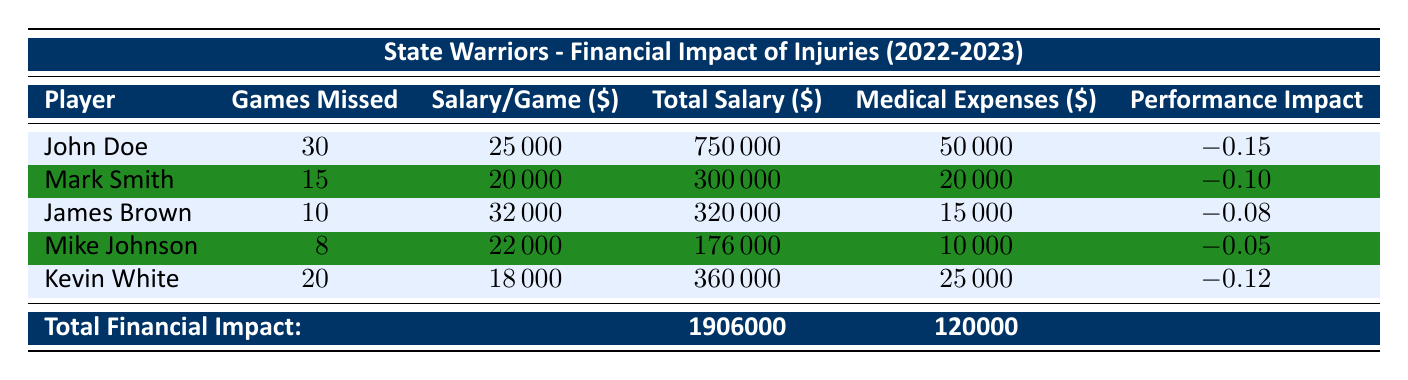What is the total salary payment for John Doe while injured? John Doe missed 30 games, and his salary per game is $25,000. To find the total salary payment while injured, multiply the number of games missed by the salary per game: 30 games * $25,000/game = $750,000.
Answer: 750000 How many games did Mark Smith miss due to injury? Directly from the table, Mark Smith's entry shows he missed 15 games.
Answer: 15 What is the total medical expenses incurred for all players listed? To find the total medical expenses, we add the medical expenses for each player: $50,000 (John Doe) + $20,000 (Mark Smith) + $15,000 (James Brown) + $10,000 (Mike Johnson) + $25,000 (Kevin White) = $120,000.
Answer: 120000 Is the performance impact for Mike Johnson positive? Mike Johnson's performance impact is -0.05, which is negative. This indicates that his absence negatively affected the team's performance.
Answer: No Who missed the most games due to injuries among the players listed? By examining the games missed for each player, John Doe missed 30 games, which is the highest among all the players.
Answer: John Doe What is the average salary per game of all the injured players? To calculate the average, first sum the salaries per game: $25,000 (John Doe) + $20,000 (Mark Smith) + $32,000 (James Brown) + $22,000 (Mike Johnson) + $18,000 (Kevin White) = $117,000. Then divide by the number of players (5): $117,000 / 5 = $23,400.
Answer: 23400 What is the impact on team performance if all injured players are considered together? To find the overall impact, average the performance impacts of all players: (-0.15 + -0.10 + -0.08 + -0.05 + -0.12) / 5 = -0.10. This indicates the cumulative effect of injuries on overall team performance.
Answer: -0.10 Did any player incur more than $25,000 in medical expenses? Yes, John Doe incurred $50,000 in medical expenses, which is greater than $25,000.
Answer: Yes Which player had the highest medical expenses? Comparing the medical expenses across all players, John Doe had the highest at $50,000.
Answer: John Doe 